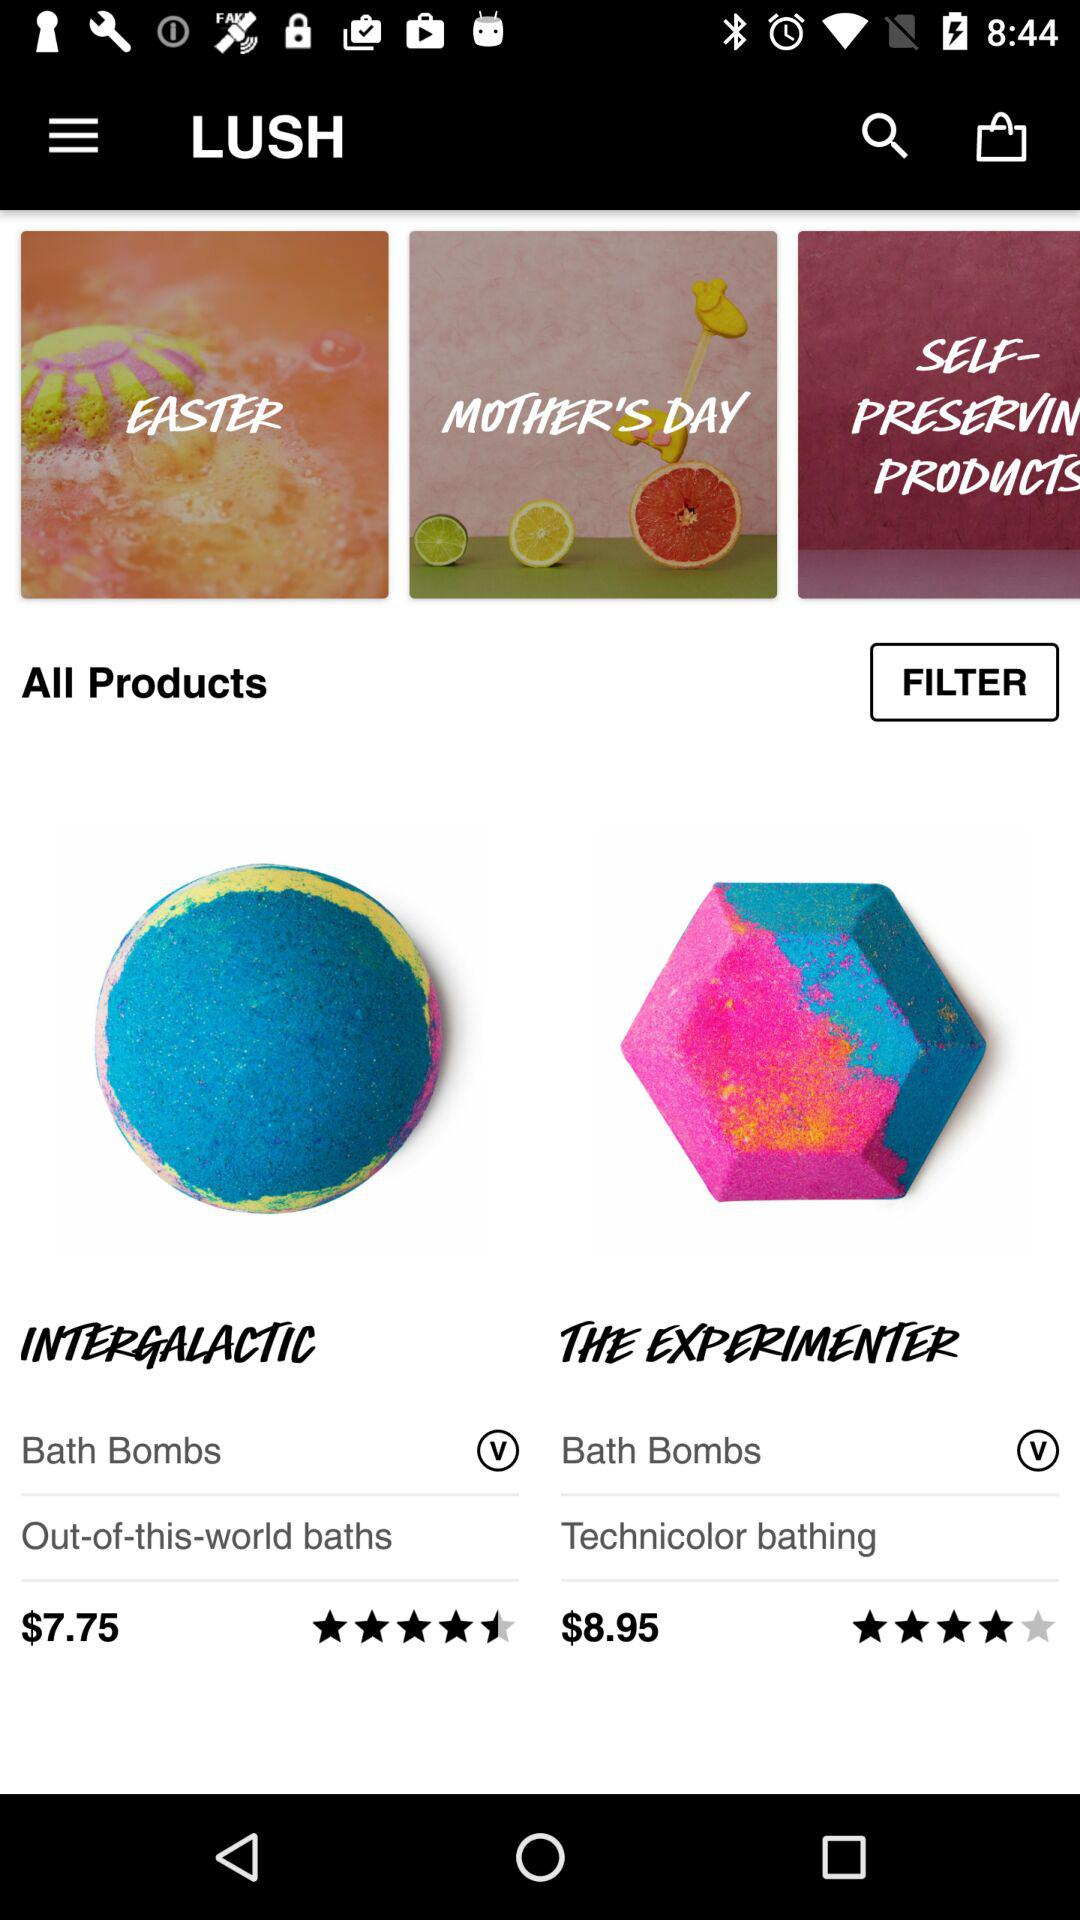What is the rating of "THE EXPERIMENTER"? The rating is 4 stars. 